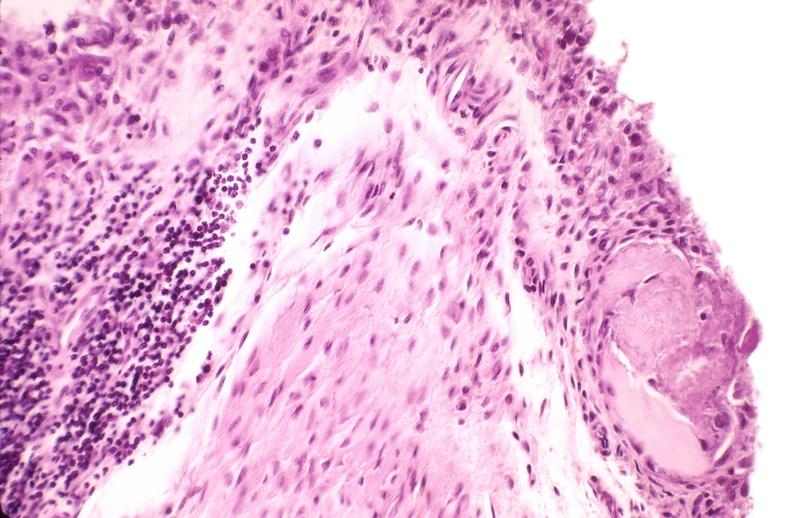s a barely seen vascular mass extruding from occipital region of skull arms and legs present?
Answer the question using a single word or phrase. No 